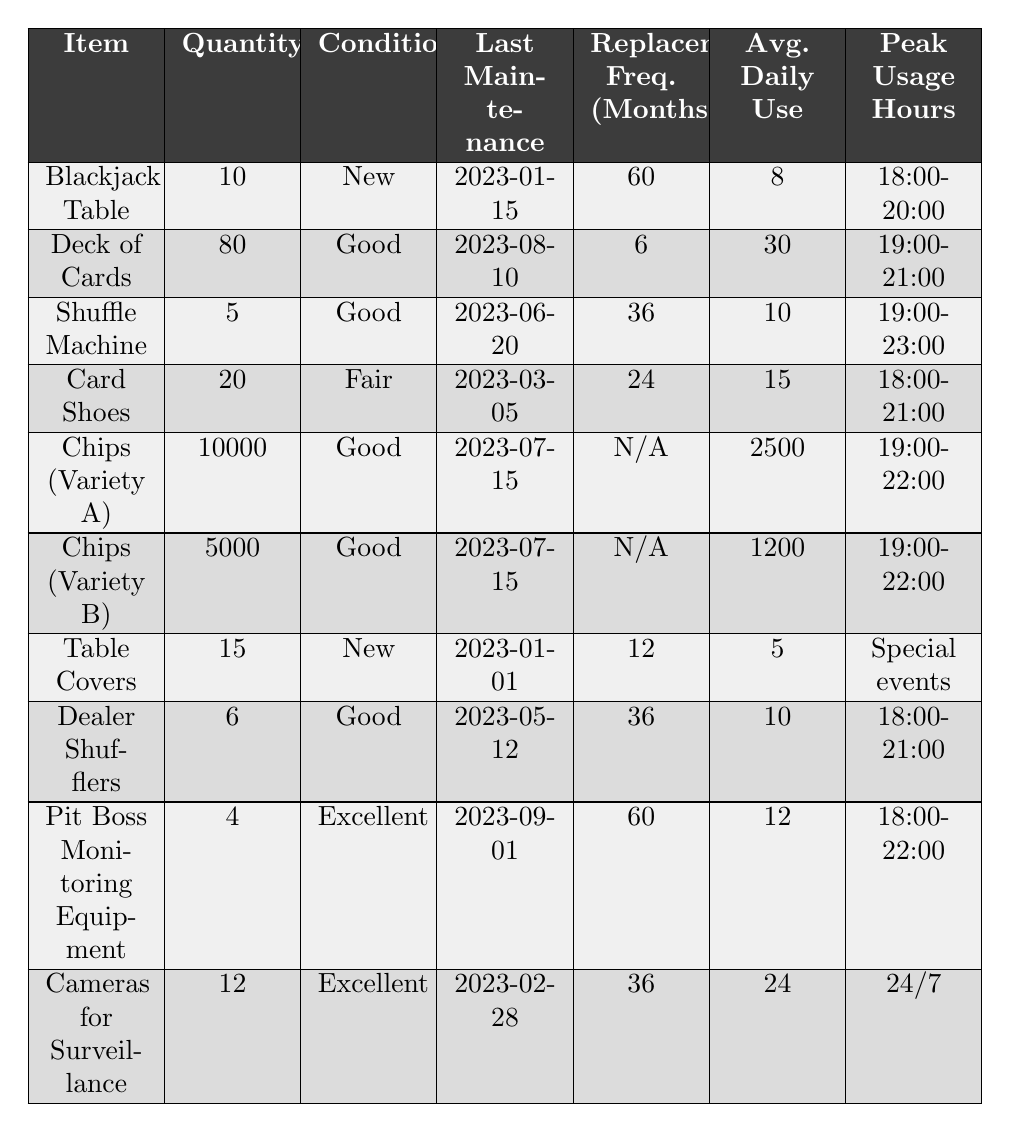What item has the highest quantity in inventory? Looking at the "Quantity" column, "Chips (Variety A)" has the highest number with a total of 10,000.
Answer: Chips (Variety A) Which item has the worst condition? The "Card Shoes" are listed as being in "Fair" condition, which is the lowest condition rating shown in the table.
Answer: Card Shoes What is the average daily use of Deck of Cards? The table indicates that "Deck of Cards" has an average daily use of 30.
Answer: 30 What is the total number of Blackjack Tables and Card Shoes combined? The quantity of Blackjack Tables is 10, and Card Shoes is 20, so 10 + 20 = 30.
Answer: 30 Which item is scheduled for maintenance next? The "Card Shoes" were last maintained on 2023-03-05 and have a replacement frequency of 24 months, making it due for maintenance in 2025. Comparing it with others, it has a further date of need than the recently maintained items, but there are no immediate scheduled tasks. However, the last maintained before August 2023 is the "Shuffle Machine."
Answer: Shuffle Machine Is the average daily use of "Chips (Variety B)" greater than or equal to 1200? Yes, the "Chips (Variety B)" have an average daily use of 1200, which meets the condition of "greater than or equal to".
Answer: Yes How many items have a replacement frequency of 60 months? The table shows there are two items with a replacement frequency of 60 months: "Blackjack Table" and "Pit Boss Monitoring Equipment", making a total of 2.
Answer: 2 If we were to calculate the total average daily use for all items listed, what would it be? First, we add each average daily use: 8 (Blackjack Table) + 30 (Deck of Cards) + 10 (Shuffle Machine) + 15 (Card Shoes) + 2500 (Chips A) + 1200 (Chips B) + 5 (Table Covers) + 10 (Dealer Shufflers) + 12 (Monitoring Equipment) + 24 (Cameras), which totals 2790. Then we divide by the number of items, 10, resulting in an average daily use of 2790 / 10 = 279.
Answer: 279 Which category of items is primarily cleaned or maintained monthly? No items in this table reflect a maintenance frequency of less than 6 months; therefore, we can deduce that none are explicitly classified under monthly cleaning protocols based on the data provided.
Answer: None What is the peak usage hour for the Chips (Variety A)? The table indicates that the peak usage hours for "Chips (Variety A)" occur from 19:00-22:00.
Answer: 19:00-22:00 